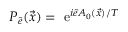Convert formula to latex. <formula><loc_0><loc_0><loc_500><loc_500>P _ { \tilde { e } } ( \vec { x } ) = e ^ { i \tilde { e } A _ { 0 } ( \vec { x } ) / T }</formula> 